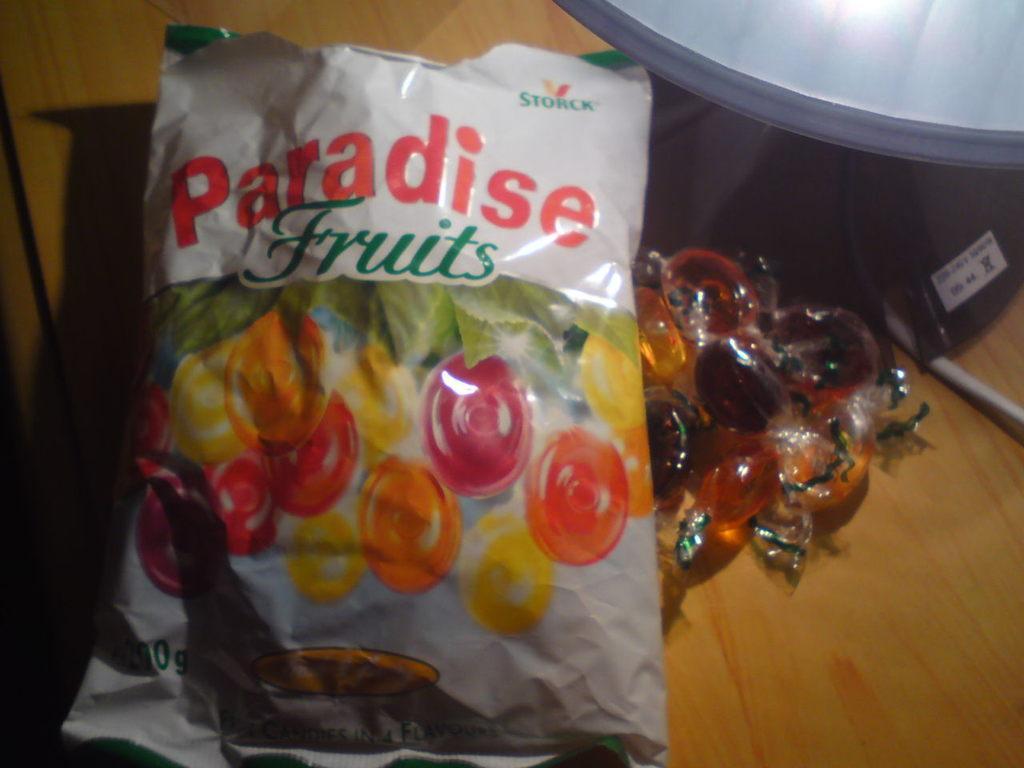In one or two sentences, can you explain what this image depicts? In this image we can see a packet with text and image, there are few candies beside the packet and an object on the table. 